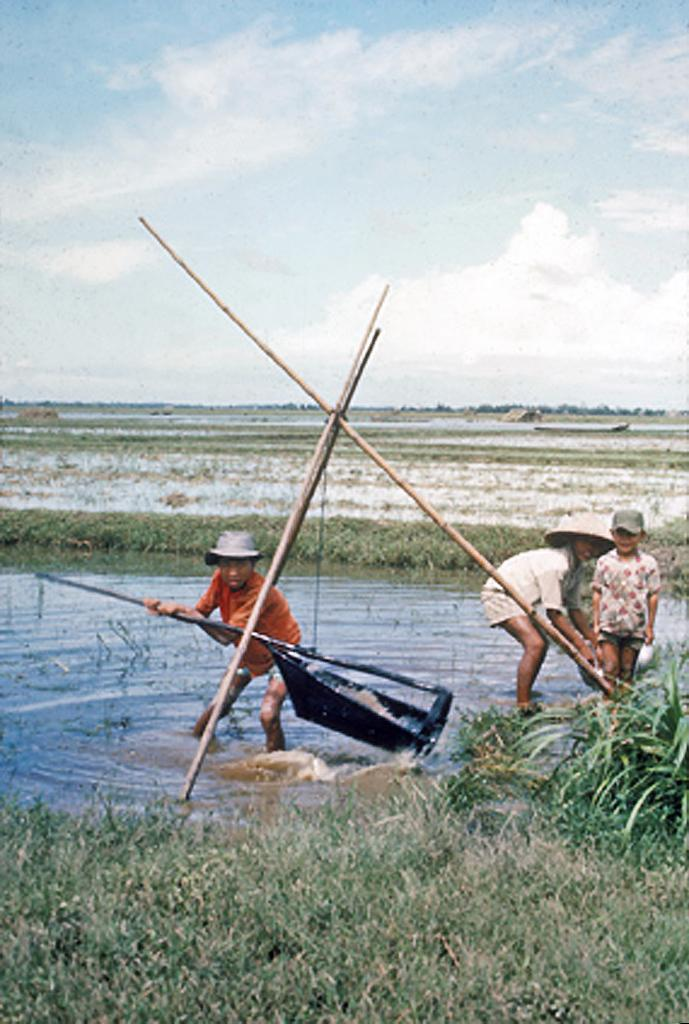What are the persons in the image wearing on their heads? The persons in the image are wearing caps. What are the persons holding in their hands? The persons are carrying sticks in their hands. What type of terrain is visible in the image? There is grass visible in the image. What else can be seen in the image besides the grass? There is water visible in the image, as well as a plant. What is visible in the background of the image? The sky is visible in the background of the image. What type of wilderness is depicted in the image? The image does not depict a wilderness; it features persons wearing caps and carrying sticks, as well as grass, water, a plant, and the sky. What type of society is represented in the image? The image does not represent a society; it is a snapshot of persons wearing caps and carrying sticks, along with the surrounding environment. 